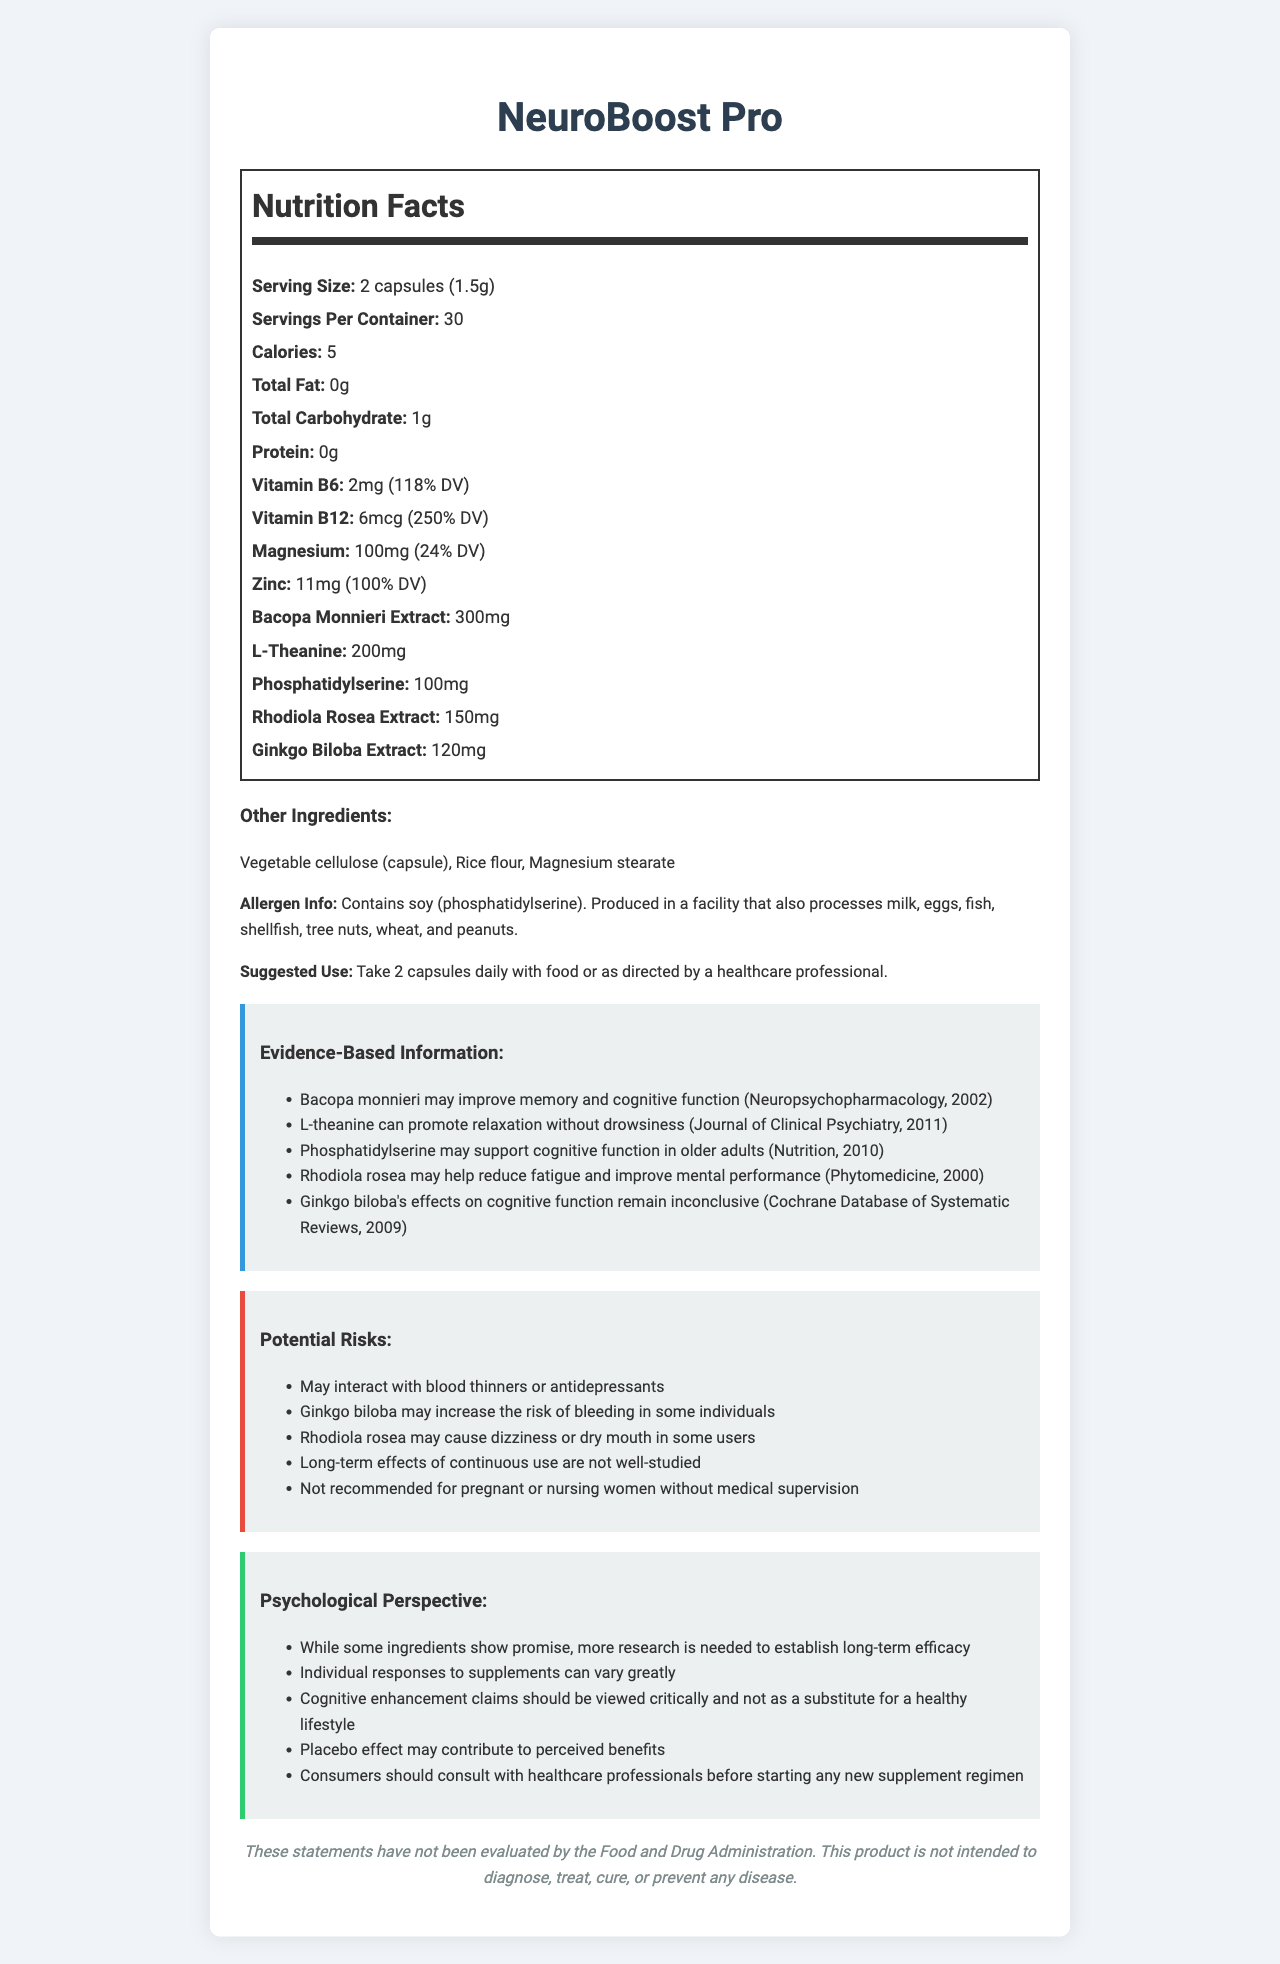what is the serving size for NeuroBoost Pro? The serving size is clearly listed as "2 capsules (1.5g)" in the Nutrition Facts section of the document.
Answer: 2 capsules (1.5g) how many servings are there in each container? The document mentions that there are "30 servings per container" in the Nutrition Facts section.
Answer: 30 servings how many calories does each serving contain? According to the Nutrition Facts, each serving of NeuroBoost Pro contains 5 calories.
Answer: 5 calories name one ingredient that helps with relaxation The document states that "L-theanine can promote relaxation without drowsiness" in the Evidence-Based Information section.
Answer: L-theanine list any two potential risks mentioned for NeuroBoost Pro These risks are listed in the Potential Risks section of the document.
Answer: May interact with blood thinners or antidepressants; Ginkgo biloba may increase the risk of bleeding in some individuals which of the following vitamins is present at more than 100% of the daily value (DV) in NeuroBoost Pro? A. Vitamin C B. Vitamin A C. Vitamin B12 D. Vitamin D The document lists Vitamin B12 as "250% DV," which is more than 100%. The other vitamins mentioned are not listed or are below 100%.
Answer: C. Vitamin B12 what is the recommended daily dosage of NeuroBoost Pro? A. 1 capsule B. 2 capsules C. 3 capsules D. 4 capsules The document suggests, "Take 2 capsules daily with food or as directed by a healthcare professional."
Answer: B. 2 capsules does NeuroBoost Pro contain protein? The Nutrition Facts states "Protein: 0g," indicating that there is no protein in the supplement.
Answer: No is NeuroBoost Pro safe for pregnant women without medical supervision? The potential risks section mentions, "Not recommended for pregnant or nursing women without medical supervision."
Answer: No summarize the main idea of the document. The document details various aspects of the NeuroBoost Pro supplement, from nutritional facts to usage recommendations, evidence-based benefits, potential risks, and the importance of a medical consultation.
Answer: The document provides comprehensive details about NeuroBoost Pro, including its nutritional content, ingredients, suggested use, evidence-based benefits, potential risks, and a psychological perspective on the supplement. The document also emphasizes consulting healthcare professionals before use. what is the long-term efficacy of NeuroBoost Pro? The document mentions that "more research is needed to establish long-term efficacy" in the psychological perspective section, indicating that the long-term effectiveness is not well-documented.
Answer: Not enough information 